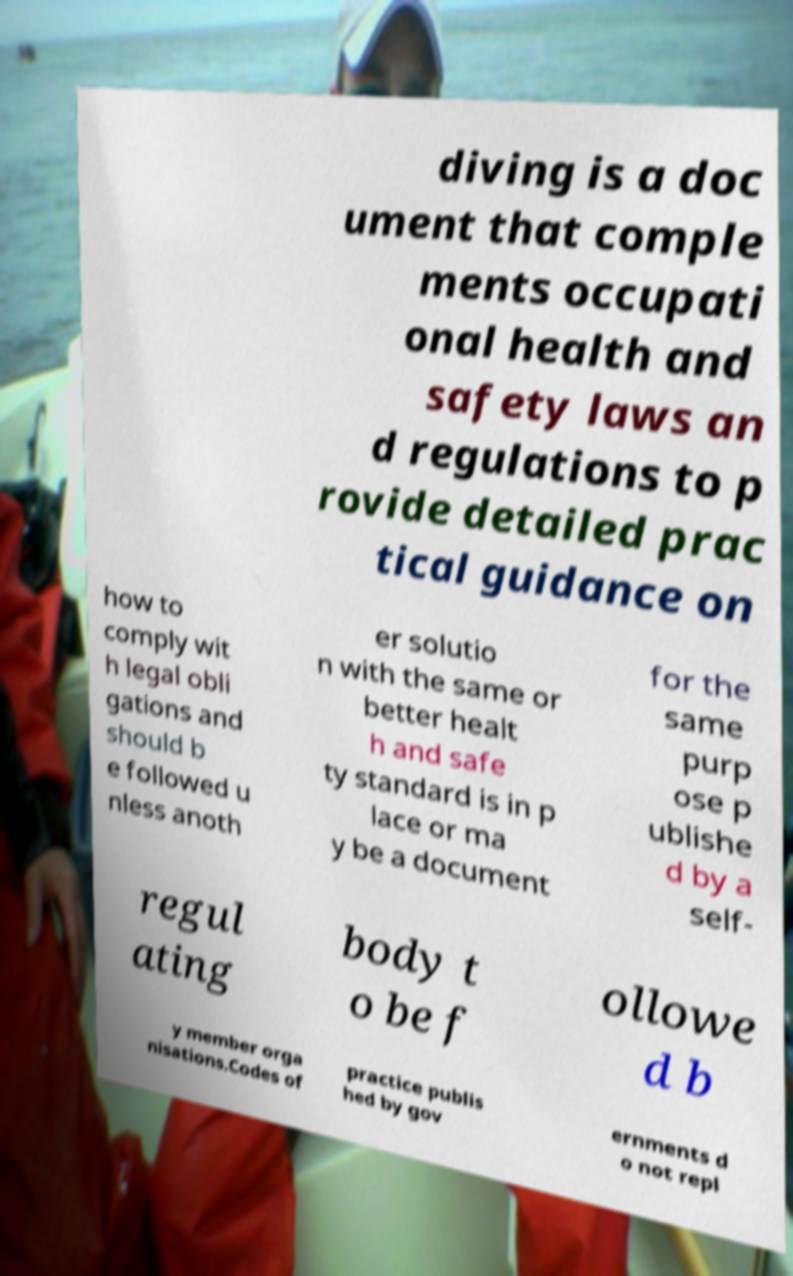I need the written content from this picture converted into text. Can you do that? diving is a doc ument that comple ments occupati onal health and safety laws an d regulations to p rovide detailed prac tical guidance on how to comply wit h legal obli gations and should b e followed u nless anoth er solutio n with the same or better healt h and safe ty standard is in p lace or ma y be a document for the same purp ose p ublishe d by a self- regul ating body t o be f ollowe d b y member orga nisations.Codes of practice publis hed by gov ernments d o not repl 